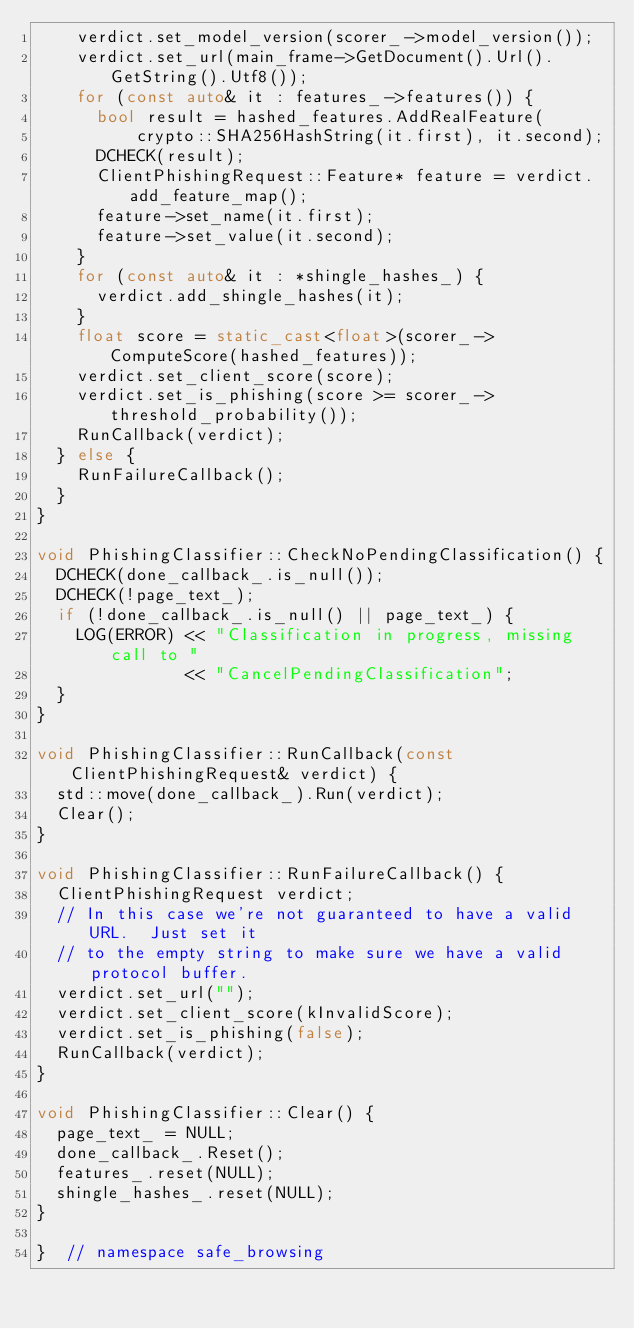Convert code to text. <code><loc_0><loc_0><loc_500><loc_500><_C++_>    verdict.set_model_version(scorer_->model_version());
    verdict.set_url(main_frame->GetDocument().Url().GetString().Utf8());
    for (const auto& it : features_->features()) {
      bool result = hashed_features.AddRealFeature(
          crypto::SHA256HashString(it.first), it.second);
      DCHECK(result);
      ClientPhishingRequest::Feature* feature = verdict.add_feature_map();
      feature->set_name(it.first);
      feature->set_value(it.second);
    }
    for (const auto& it : *shingle_hashes_) {
      verdict.add_shingle_hashes(it);
    }
    float score = static_cast<float>(scorer_->ComputeScore(hashed_features));
    verdict.set_client_score(score);
    verdict.set_is_phishing(score >= scorer_->threshold_probability());
    RunCallback(verdict);
  } else {
    RunFailureCallback();
  }
}

void PhishingClassifier::CheckNoPendingClassification() {
  DCHECK(done_callback_.is_null());
  DCHECK(!page_text_);
  if (!done_callback_.is_null() || page_text_) {
    LOG(ERROR) << "Classification in progress, missing call to "
               << "CancelPendingClassification";
  }
}

void PhishingClassifier::RunCallback(const ClientPhishingRequest& verdict) {
  std::move(done_callback_).Run(verdict);
  Clear();
}

void PhishingClassifier::RunFailureCallback() {
  ClientPhishingRequest verdict;
  // In this case we're not guaranteed to have a valid URL.  Just set it
  // to the empty string to make sure we have a valid protocol buffer.
  verdict.set_url("");
  verdict.set_client_score(kInvalidScore);
  verdict.set_is_phishing(false);
  RunCallback(verdict);
}

void PhishingClassifier::Clear() {
  page_text_ = NULL;
  done_callback_.Reset();
  features_.reset(NULL);
  shingle_hashes_.reset(NULL);
}

}  // namespace safe_browsing
</code> 